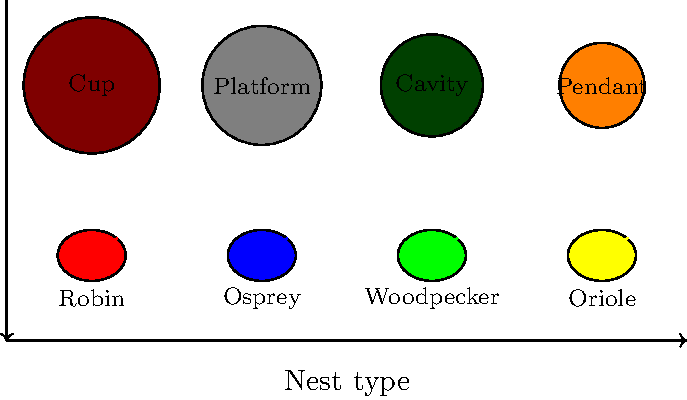Match the bird nest structures shown in the diagram with their corresponding species. Which bird is associated with the pendant nest? To solve this problem, we need to analyze the relationship between bird species and their nest types:

1. Cup nest: This is a common nest type for many songbirds. In this case, it's associated with the Robin, known for building cup-shaped nests.

2. Platform nest: This large, flat nest is typically built by larger birds. Here, it's matched with the Osprey, a fish-eating raptor that constructs platform nests near water bodies.

3. Cavity nest: This type of nest is created in tree holes or other cavities. Woodpeckers are well-known for excavating cavity nests in trees.

4. Pendant nest: This hanging, bag-like nest is characteristic of Orioles. They weave intricate pendant nests that hang from tree branches.

By matching each nest type with its corresponding bird species, we can determine that the pendant nest is associated with the Oriole.
Answer: Oriole 